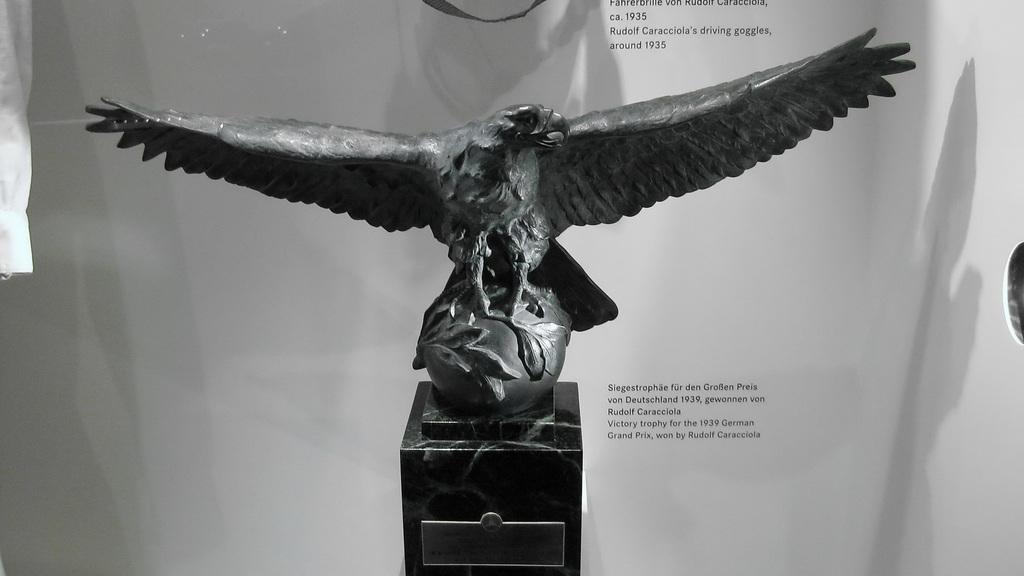Can you describe this image briefly? In this image, we can see a statue on an object. In the background, we can see the white colored wall with some text. We can also see an object on the right and an object on the left. We can also see an object at the top. 